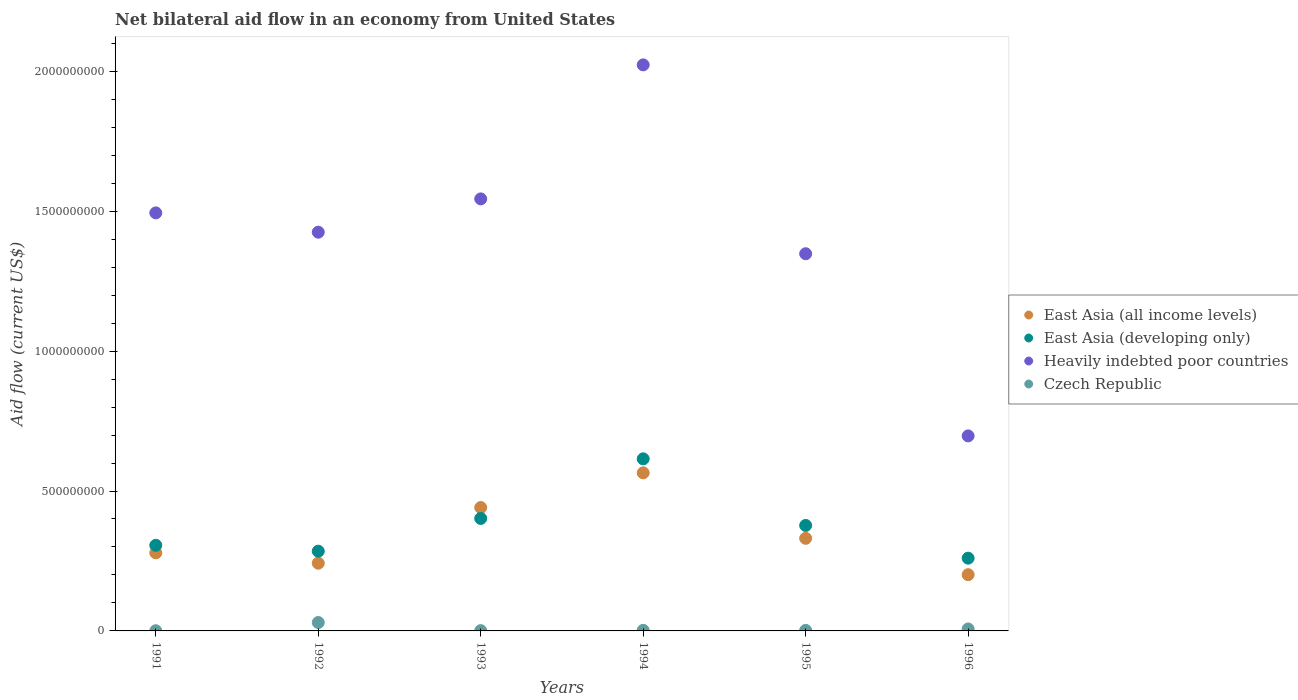How many different coloured dotlines are there?
Provide a succinct answer. 4. What is the net bilateral aid flow in East Asia (all income levels) in 1995?
Provide a succinct answer. 3.31e+08. Across all years, what is the maximum net bilateral aid flow in East Asia (all income levels)?
Keep it short and to the point. 5.65e+08. Across all years, what is the minimum net bilateral aid flow in East Asia (developing only)?
Offer a very short reply. 2.60e+08. In which year was the net bilateral aid flow in East Asia (all income levels) maximum?
Make the answer very short. 1994. What is the total net bilateral aid flow in Heavily indebted poor countries in the graph?
Keep it short and to the point. 8.53e+09. What is the difference between the net bilateral aid flow in East Asia (all income levels) in 1994 and that in 1996?
Your answer should be very brief. 3.64e+08. What is the difference between the net bilateral aid flow in Czech Republic in 1993 and the net bilateral aid flow in East Asia (all income levels) in 1995?
Your answer should be compact. -3.30e+08. What is the average net bilateral aid flow in East Asia (all income levels) per year?
Your answer should be compact. 3.43e+08. In the year 1992, what is the difference between the net bilateral aid flow in East Asia (developing only) and net bilateral aid flow in East Asia (all income levels)?
Provide a short and direct response. 4.30e+07. Is the net bilateral aid flow in East Asia (all income levels) in 1993 less than that in 1996?
Provide a succinct answer. No. Is the difference between the net bilateral aid flow in East Asia (developing only) in 1991 and 1995 greater than the difference between the net bilateral aid flow in East Asia (all income levels) in 1991 and 1995?
Keep it short and to the point. No. What is the difference between the highest and the second highest net bilateral aid flow in Heavily indebted poor countries?
Your answer should be very brief. 4.79e+08. What is the difference between the highest and the lowest net bilateral aid flow in East Asia (developing only)?
Make the answer very short. 3.55e+08. In how many years, is the net bilateral aid flow in Heavily indebted poor countries greater than the average net bilateral aid flow in Heavily indebted poor countries taken over all years?
Provide a succinct answer. 4. Is it the case that in every year, the sum of the net bilateral aid flow in Heavily indebted poor countries and net bilateral aid flow in East Asia (developing only)  is greater than the sum of net bilateral aid flow in East Asia (all income levels) and net bilateral aid flow in Czech Republic?
Keep it short and to the point. Yes. Is the net bilateral aid flow in Heavily indebted poor countries strictly greater than the net bilateral aid flow in East Asia (developing only) over the years?
Keep it short and to the point. Yes. Is the net bilateral aid flow in East Asia (developing only) strictly less than the net bilateral aid flow in Heavily indebted poor countries over the years?
Make the answer very short. Yes. How many dotlines are there?
Your answer should be compact. 4. What is the difference between two consecutive major ticks on the Y-axis?
Your response must be concise. 5.00e+08. Does the graph contain any zero values?
Ensure brevity in your answer.  No. Does the graph contain grids?
Your answer should be compact. No. Where does the legend appear in the graph?
Offer a very short reply. Center right. How are the legend labels stacked?
Your answer should be compact. Vertical. What is the title of the graph?
Your answer should be very brief. Net bilateral aid flow in an economy from United States. Does "Bosnia and Herzegovina" appear as one of the legend labels in the graph?
Your answer should be very brief. No. What is the Aid flow (current US$) of East Asia (all income levels) in 1991?
Your answer should be very brief. 2.79e+08. What is the Aid flow (current US$) in East Asia (developing only) in 1991?
Make the answer very short. 3.06e+08. What is the Aid flow (current US$) of Heavily indebted poor countries in 1991?
Provide a short and direct response. 1.49e+09. What is the Aid flow (current US$) in Czech Republic in 1991?
Your answer should be very brief. 7.00e+05. What is the Aid flow (current US$) in East Asia (all income levels) in 1992?
Your answer should be very brief. 2.42e+08. What is the Aid flow (current US$) of East Asia (developing only) in 1992?
Your response must be concise. 2.85e+08. What is the Aid flow (current US$) of Heavily indebted poor countries in 1992?
Your response must be concise. 1.42e+09. What is the Aid flow (current US$) in Czech Republic in 1992?
Offer a terse response. 3.00e+07. What is the Aid flow (current US$) of East Asia (all income levels) in 1993?
Give a very brief answer. 4.41e+08. What is the Aid flow (current US$) of East Asia (developing only) in 1993?
Your answer should be compact. 4.02e+08. What is the Aid flow (current US$) in Heavily indebted poor countries in 1993?
Give a very brief answer. 1.54e+09. What is the Aid flow (current US$) of Czech Republic in 1993?
Your response must be concise. 1.00e+06. What is the Aid flow (current US$) of East Asia (all income levels) in 1994?
Provide a short and direct response. 5.65e+08. What is the Aid flow (current US$) in East Asia (developing only) in 1994?
Provide a short and direct response. 6.15e+08. What is the Aid flow (current US$) of Heavily indebted poor countries in 1994?
Make the answer very short. 2.02e+09. What is the Aid flow (current US$) in East Asia (all income levels) in 1995?
Provide a short and direct response. 3.31e+08. What is the Aid flow (current US$) of East Asia (developing only) in 1995?
Give a very brief answer. 3.77e+08. What is the Aid flow (current US$) of Heavily indebted poor countries in 1995?
Your answer should be compact. 1.35e+09. What is the Aid flow (current US$) in Czech Republic in 1995?
Ensure brevity in your answer.  2.00e+06. What is the Aid flow (current US$) of East Asia (all income levels) in 1996?
Provide a succinct answer. 2.01e+08. What is the Aid flow (current US$) in East Asia (developing only) in 1996?
Your response must be concise. 2.60e+08. What is the Aid flow (current US$) in Heavily indebted poor countries in 1996?
Provide a short and direct response. 6.97e+08. What is the Aid flow (current US$) of Czech Republic in 1996?
Give a very brief answer. 7.00e+06. Across all years, what is the maximum Aid flow (current US$) in East Asia (all income levels)?
Offer a terse response. 5.65e+08. Across all years, what is the maximum Aid flow (current US$) of East Asia (developing only)?
Provide a succinct answer. 6.15e+08. Across all years, what is the maximum Aid flow (current US$) of Heavily indebted poor countries?
Your response must be concise. 2.02e+09. Across all years, what is the maximum Aid flow (current US$) of Czech Republic?
Make the answer very short. 3.00e+07. Across all years, what is the minimum Aid flow (current US$) of East Asia (all income levels)?
Give a very brief answer. 2.01e+08. Across all years, what is the minimum Aid flow (current US$) of East Asia (developing only)?
Make the answer very short. 2.60e+08. Across all years, what is the minimum Aid flow (current US$) of Heavily indebted poor countries?
Provide a short and direct response. 6.97e+08. Across all years, what is the minimum Aid flow (current US$) in Czech Republic?
Your answer should be compact. 7.00e+05. What is the total Aid flow (current US$) of East Asia (all income levels) in the graph?
Offer a very short reply. 2.06e+09. What is the total Aid flow (current US$) in East Asia (developing only) in the graph?
Offer a terse response. 2.24e+09. What is the total Aid flow (current US$) in Heavily indebted poor countries in the graph?
Offer a very short reply. 8.53e+09. What is the total Aid flow (current US$) in Czech Republic in the graph?
Give a very brief answer. 4.27e+07. What is the difference between the Aid flow (current US$) in East Asia (all income levels) in 1991 and that in 1992?
Give a very brief answer. 3.70e+07. What is the difference between the Aid flow (current US$) of East Asia (developing only) in 1991 and that in 1992?
Your answer should be compact. 2.10e+07. What is the difference between the Aid flow (current US$) of Heavily indebted poor countries in 1991 and that in 1992?
Provide a short and direct response. 6.90e+07. What is the difference between the Aid flow (current US$) of Czech Republic in 1991 and that in 1992?
Your response must be concise. -2.93e+07. What is the difference between the Aid flow (current US$) of East Asia (all income levels) in 1991 and that in 1993?
Offer a very short reply. -1.62e+08. What is the difference between the Aid flow (current US$) in East Asia (developing only) in 1991 and that in 1993?
Offer a terse response. -9.60e+07. What is the difference between the Aid flow (current US$) of Heavily indebted poor countries in 1991 and that in 1993?
Keep it short and to the point. -5.00e+07. What is the difference between the Aid flow (current US$) of East Asia (all income levels) in 1991 and that in 1994?
Offer a very short reply. -2.86e+08. What is the difference between the Aid flow (current US$) in East Asia (developing only) in 1991 and that in 1994?
Keep it short and to the point. -3.09e+08. What is the difference between the Aid flow (current US$) in Heavily indebted poor countries in 1991 and that in 1994?
Provide a succinct answer. -5.29e+08. What is the difference between the Aid flow (current US$) in Czech Republic in 1991 and that in 1994?
Offer a very short reply. -1.30e+06. What is the difference between the Aid flow (current US$) of East Asia (all income levels) in 1991 and that in 1995?
Provide a short and direct response. -5.20e+07. What is the difference between the Aid flow (current US$) of East Asia (developing only) in 1991 and that in 1995?
Provide a succinct answer. -7.10e+07. What is the difference between the Aid flow (current US$) of Heavily indebted poor countries in 1991 and that in 1995?
Your response must be concise. 1.46e+08. What is the difference between the Aid flow (current US$) in Czech Republic in 1991 and that in 1995?
Your answer should be very brief. -1.30e+06. What is the difference between the Aid flow (current US$) in East Asia (all income levels) in 1991 and that in 1996?
Keep it short and to the point. 7.80e+07. What is the difference between the Aid flow (current US$) of East Asia (developing only) in 1991 and that in 1996?
Make the answer very short. 4.60e+07. What is the difference between the Aid flow (current US$) of Heavily indebted poor countries in 1991 and that in 1996?
Provide a short and direct response. 7.97e+08. What is the difference between the Aid flow (current US$) in Czech Republic in 1991 and that in 1996?
Provide a short and direct response. -6.30e+06. What is the difference between the Aid flow (current US$) of East Asia (all income levels) in 1992 and that in 1993?
Offer a very short reply. -1.99e+08. What is the difference between the Aid flow (current US$) of East Asia (developing only) in 1992 and that in 1993?
Give a very brief answer. -1.17e+08. What is the difference between the Aid flow (current US$) in Heavily indebted poor countries in 1992 and that in 1993?
Give a very brief answer. -1.19e+08. What is the difference between the Aid flow (current US$) of Czech Republic in 1992 and that in 1993?
Provide a short and direct response. 2.90e+07. What is the difference between the Aid flow (current US$) of East Asia (all income levels) in 1992 and that in 1994?
Your answer should be very brief. -3.23e+08. What is the difference between the Aid flow (current US$) in East Asia (developing only) in 1992 and that in 1994?
Make the answer very short. -3.30e+08. What is the difference between the Aid flow (current US$) in Heavily indebted poor countries in 1992 and that in 1994?
Offer a very short reply. -5.98e+08. What is the difference between the Aid flow (current US$) of Czech Republic in 1992 and that in 1994?
Offer a very short reply. 2.80e+07. What is the difference between the Aid flow (current US$) in East Asia (all income levels) in 1992 and that in 1995?
Provide a short and direct response. -8.90e+07. What is the difference between the Aid flow (current US$) of East Asia (developing only) in 1992 and that in 1995?
Keep it short and to the point. -9.20e+07. What is the difference between the Aid flow (current US$) of Heavily indebted poor countries in 1992 and that in 1995?
Provide a short and direct response. 7.70e+07. What is the difference between the Aid flow (current US$) of Czech Republic in 1992 and that in 1995?
Offer a very short reply. 2.80e+07. What is the difference between the Aid flow (current US$) in East Asia (all income levels) in 1992 and that in 1996?
Your response must be concise. 4.10e+07. What is the difference between the Aid flow (current US$) in East Asia (developing only) in 1992 and that in 1996?
Your response must be concise. 2.50e+07. What is the difference between the Aid flow (current US$) of Heavily indebted poor countries in 1992 and that in 1996?
Keep it short and to the point. 7.28e+08. What is the difference between the Aid flow (current US$) in Czech Republic in 1992 and that in 1996?
Make the answer very short. 2.30e+07. What is the difference between the Aid flow (current US$) in East Asia (all income levels) in 1993 and that in 1994?
Give a very brief answer. -1.24e+08. What is the difference between the Aid flow (current US$) in East Asia (developing only) in 1993 and that in 1994?
Provide a succinct answer. -2.13e+08. What is the difference between the Aid flow (current US$) in Heavily indebted poor countries in 1993 and that in 1994?
Your answer should be compact. -4.79e+08. What is the difference between the Aid flow (current US$) in Czech Republic in 1993 and that in 1994?
Make the answer very short. -1.00e+06. What is the difference between the Aid flow (current US$) of East Asia (all income levels) in 1993 and that in 1995?
Keep it short and to the point. 1.10e+08. What is the difference between the Aid flow (current US$) of East Asia (developing only) in 1993 and that in 1995?
Your answer should be compact. 2.50e+07. What is the difference between the Aid flow (current US$) of Heavily indebted poor countries in 1993 and that in 1995?
Ensure brevity in your answer.  1.96e+08. What is the difference between the Aid flow (current US$) in Czech Republic in 1993 and that in 1995?
Ensure brevity in your answer.  -1.00e+06. What is the difference between the Aid flow (current US$) of East Asia (all income levels) in 1993 and that in 1996?
Ensure brevity in your answer.  2.40e+08. What is the difference between the Aid flow (current US$) in East Asia (developing only) in 1993 and that in 1996?
Offer a terse response. 1.42e+08. What is the difference between the Aid flow (current US$) of Heavily indebted poor countries in 1993 and that in 1996?
Your answer should be compact. 8.47e+08. What is the difference between the Aid flow (current US$) of Czech Republic in 1993 and that in 1996?
Provide a short and direct response. -6.00e+06. What is the difference between the Aid flow (current US$) of East Asia (all income levels) in 1994 and that in 1995?
Keep it short and to the point. 2.34e+08. What is the difference between the Aid flow (current US$) of East Asia (developing only) in 1994 and that in 1995?
Offer a terse response. 2.38e+08. What is the difference between the Aid flow (current US$) of Heavily indebted poor countries in 1994 and that in 1995?
Ensure brevity in your answer.  6.75e+08. What is the difference between the Aid flow (current US$) in East Asia (all income levels) in 1994 and that in 1996?
Ensure brevity in your answer.  3.64e+08. What is the difference between the Aid flow (current US$) of East Asia (developing only) in 1994 and that in 1996?
Offer a terse response. 3.55e+08. What is the difference between the Aid flow (current US$) of Heavily indebted poor countries in 1994 and that in 1996?
Keep it short and to the point. 1.33e+09. What is the difference between the Aid flow (current US$) in Czech Republic in 1994 and that in 1996?
Provide a short and direct response. -5.00e+06. What is the difference between the Aid flow (current US$) in East Asia (all income levels) in 1995 and that in 1996?
Provide a succinct answer. 1.30e+08. What is the difference between the Aid flow (current US$) in East Asia (developing only) in 1995 and that in 1996?
Offer a terse response. 1.17e+08. What is the difference between the Aid flow (current US$) of Heavily indebted poor countries in 1995 and that in 1996?
Your answer should be compact. 6.51e+08. What is the difference between the Aid flow (current US$) of Czech Republic in 1995 and that in 1996?
Make the answer very short. -5.00e+06. What is the difference between the Aid flow (current US$) in East Asia (all income levels) in 1991 and the Aid flow (current US$) in East Asia (developing only) in 1992?
Your answer should be compact. -6.00e+06. What is the difference between the Aid flow (current US$) of East Asia (all income levels) in 1991 and the Aid flow (current US$) of Heavily indebted poor countries in 1992?
Make the answer very short. -1.15e+09. What is the difference between the Aid flow (current US$) in East Asia (all income levels) in 1991 and the Aid flow (current US$) in Czech Republic in 1992?
Provide a short and direct response. 2.49e+08. What is the difference between the Aid flow (current US$) of East Asia (developing only) in 1991 and the Aid flow (current US$) of Heavily indebted poor countries in 1992?
Ensure brevity in your answer.  -1.12e+09. What is the difference between the Aid flow (current US$) in East Asia (developing only) in 1991 and the Aid flow (current US$) in Czech Republic in 1992?
Offer a very short reply. 2.76e+08. What is the difference between the Aid flow (current US$) of Heavily indebted poor countries in 1991 and the Aid flow (current US$) of Czech Republic in 1992?
Make the answer very short. 1.46e+09. What is the difference between the Aid flow (current US$) in East Asia (all income levels) in 1991 and the Aid flow (current US$) in East Asia (developing only) in 1993?
Offer a very short reply. -1.23e+08. What is the difference between the Aid flow (current US$) of East Asia (all income levels) in 1991 and the Aid flow (current US$) of Heavily indebted poor countries in 1993?
Offer a very short reply. -1.26e+09. What is the difference between the Aid flow (current US$) in East Asia (all income levels) in 1991 and the Aid flow (current US$) in Czech Republic in 1993?
Offer a very short reply. 2.78e+08. What is the difference between the Aid flow (current US$) in East Asia (developing only) in 1991 and the Aid flow (current US$) in Heavily indebted poor countries in 1993?
Your answer should be compact. -1.24e+09. What is the difference between the Aid flow (current US$) in East Asia (developing only) in 1991 and the Aid flow (current US$) in Czech Republic in 1993?
Your response must be concise. 3.05e+08. What is the difference between the Aid flow (current US$) in Heavily indebted poor countries in 1991 and the Aid flow (current US$) in Czech Republic in 1993?
Your answer should be compact. 1.49e+09. What is the difference between the Aid flow (current US$) of East Asia (all income levels) in 1991 and the Aid flow (current US$) of East Asia (developing only) in 1994?
Make the answer very short. -3.36e+08. What is the difference between the Aid flow (current US$) of East Asia (all income levels) in 1991 and the Aid flow (current US$) of Heavily indebted poor countries in 1994?
Give a very brief answer. -1.74e+09. What is the difference between the Aid flow (current US$) of East Asia (all income levels) in 1991 and the Aid flow (current US$) of Czech Republic in 1994?
Provide a short and direct response. 2.77e+08. What is the difference between the Aid flow (current US$) of East Asia (developing only) in 1991 and the Aid flow (current US$) of Heavily indebted poor countries in 1994?
Your answer should be compact. -1.72e+09. What is the difference between the Aid flow (current US$) of East Asia (developing only) in 1991 and the Aid flow (current US$) of Czech Republic in 1994?
Give a very brief answer. 3.04e+08. What is the difference between the Aid flow (current US$) of Heavily indebted poor countries in 1991 and the Aid flow (current US$) of Czech Republic in 1994?
Provide a short and direct response. 1.49e+09. What is the difference between the Aid flow (current US$) in East Asia (all income levels) in 1991 and the Aid flow (current US$) in East Asia (developing only) in 1995?
Your answer should be compact. -9.80e+07. What is the difference between the Aid flow (current US$) in East Asia (all income levels) in 1991 and the Aid flow (current US$) in Heavily indebted poor countries in 1995?
Give a very brief answer. -1.07e+09. What is the difference between the Aid flow (current US$) of East Asia (all income levels) in 1991 and the Aid flow (current US$) of Czech Republic in 1995?
Offer a very short reply. 2.77e+08. What is the difference between the Aid flow (current US$) of East Asia (developing only) in 1991 and the Aid flow (current US$) of Heavily indebted poor countries in 1995?
Your response must be concise. -1.04e+09. What is the difference between the Aid flow (current US$) in East Asia (developing only) in 1991 and the Aid flow (current US$) in Czech Republic in 1995?
Your response must be concise. 3.04e+08. What is the difference between the Aid flow (current US$) of Heavily indebted poor countries in 1991 and the Aid flow (current US$) of Czech Republic in 1995?
Offer a very short reply. 1.49e+09. What is the difference between the Aid flow (current US$) in East Asia (all income levels) in 1991 and the Aid flow (current US$) in East Asia (developing only) in 1996?
Your response must be concise. 1.90e+07. What is the difference between the Aid flow (current US$) in East Asia (all income levels) in 1991 and the Aid flow (current US$) in Heavily indebted poor countries in 1996?
Provide a succinct answer. -4.18e+08. What is the difference between the Aid flow (current US$) of East Asia (all income levels) in 1991 and the Aid flow (current US$) of Czech Republic in 1996?
Give a very brief answer. 2.72e+08. What is the difference between the Aid flow (current US$) of East Asia (developing only) in 1991 and the Aid flow (current US$) of Heavily indebted poor countries in 1996?
Give a very brief answer. -3.91e+08. What is the difference between the Aid flow (current US$) of East Asia (developing only) in 1991 and the Aid flow (current US$) of Czech Republic in 1996?
Keep it short and to the point. 2.99e+08. What is the difference between the Aid flow (current US$) of Heavily indebted poor countries in 1991 and the Aid flow (current US$) of Czech Republic in 1996?
Your answer should be compact. 1.49e+09. What is the difference between the Aid flow (current US$) of East Asia (all income levels) in 1992 and the Aid flow (current US$) of East Asia (developing only) in 1993?
Your response must be concise. -1.60e+08. What is the difference between the Aid flow (current US$) of East Asia (all income levels) in 1992 and the Aid flow (current US$) of Heavily indebted poor countries in 1993?
Make the answer very short. -1.30e+09. What is the difference between the Aid flow (current US$) of East Asia (all income levels) in 1992 and the Aid flow (current US$) of Czech Republic in 1993?
Give a very brief answer. 2.41e+08. What is the difference between the Aid flow (current US$) of East Asia (developing only) in 1992 and the Aid flow (current US$) of Heavily indebted poor countries in 1993?
Offer a terse response. -1.26e+09. What is the difference between the Aid flow (current US$) in East Asia (developing only) in 1992 and the Aid flow (current US$) in Czech Republic in 1993?
Your response must be concise. 2.84e+08. What is the difference between the Aid flow (current US$) in Heavily indebted poor countries in 1992 and the Aid flow (current US$) in Czech Republic in 1993?
Your answer should be very brief. 1.42e+09. What is the difference between the Aid flow (current US$) in East Asia (all income levels) in 1992 and the Aid flow (current US$) in East Asia (developing only) in 1994?
Provide a succinct answer. -3.73e+08. What is the difference between the Aid flow (current US$) in East Asia (all income levels) in 1992 and the Aid flow (current US$) in Heavily indebted poor countries in 1994?
Provide a short and direct response. -1.78e+09. What is the difference between the Aid flow (current US$) of East Asia (all income levels) in 1992 and the Aid flow (current US$) of Czech Republic in 1994?
Ensure brevity in your answer.  2.40e+08. What is the difference between the Aid flow (current US$) in East Asia (developing only) in 1992 and the Aid flow (current US$) in Heavily indebted poor countries in 1994?
Ensure brevity in your answer.  -1.74e+09. What is the difference between the Aid flow (current US$) of East Asia (developing only) in 1992 and the Aid flow (current US$) of Czech Republic in 1994?
Provide a short and direct response. 2.83e+08. What is the difference between the Aid flow (current US$) in Heavily indebted poor countries in 1992 and the Aid flow (current US$) in Czech Republic in 1994?
Ensure brevity in your answer.  1.42e+09. What is the difference between the Aid flow (current US$) of East Asia (all income levels) in 1992 and the Aid flow (current US$) of East Asia (developing only) in 1995?
Ensure brevity in your answer.  -1.35e+08. What is the difference between the Aid flow (current US$) of East Asia (all income levels) in 1992 and the Aid flow (current US$) of Heavily indebted poor countries in 1995?
Your answer should be compact. -1.11e+09. What is the difference between the Aid flow (current US$) of East Asia (all income levels) in 1992 and the Aid flow (current US$) of Czech Republic in 1995?
Your answer should be very brief. 2.40e+08. What is the difference between the Aid flow (current US$) in East Asia (developing only) in 1992 and the Aid flow (current US$) in Heavily indebted poor countries in 1995?
Provide a succinct answer. -1.06e+09. What is the difference between the Aid flow (current US$) of East Asia (developing only) in 1992 and the Aid flow (current US$) of Czech Republic in 1995?
Your answer should be very brief. 2.83e+08. What is the difference between the Aid flow (current US$) of Heavily indebted poor countries in 1992 and the Aid flow (current US$) of Czech Republic in 1995?
Provide a succinct answer. 1.42e+09. What is the difference between the Aid flow (current US$) in East Asia (all income levels) in 1992 and the Aid flow (current US$) in East Asia (developing only) in 1996?
Keep it short and to the point. -1.80e+07. What is the difference between the Aid flow (current US$) of East Asia (all income levels) in 1992 and the Aid flow (current US$) of Heavily indebted poor countries in 1996?
Your answer should be very brief. -4.55e+08. What is the difference between the Aid flow (current US$) in East Asia (all income levels) in 1992 and the Aid flow (current US$) in Czech Republic in 1996?
Give a very brief answer. 2.35e+08. What is the difference between the Aid flow (current US$) of East Asia (developing only) in 1992 and the Aid flow (current US$) of Heavily indebted poor countries in 1996?
Offer a very short reply. -4.12e+08. What is the difference between the Aid flow (current US$) of East Asia (developing only) in 1992 and the Aid flow (current US$) of Czech Republic in 1996?
Give a very brief answer. 2.78e+08. What is the difference between the Aid flow (current US$) of Heavily indebted poor countries in 1992 and the Aid flow (current US$) of Czech Republic in 1996?
Provide a succinct answer. 1.42e+09. What is the difference between the Aid flow (current US$) of East Asia (all income levels) in 1993 and the Aid flow (current US$) of East Asia (developing only) in 1994?
Your answer should be very brief. -1.74e+08. What is the difference between the Aid flow (current US$) of East Asia (all income levels) in 1993 and the Aid flow (current US$) of Heavily indebted poor countries in 1994?
Your response must be concise. -1.58e+09. What is the difference between the Aid flow (current US$) of East Asia (all income levels) in 1993 and the Aid flow (current US$) of Czech Republic in 1994?
Provide a succinct answer. 4.39e+08. What is the difference between the Aid flow (current US$) of East Asia (developing only) in 1993 and the Aid flow (current US$) of Heavily indebted poor countries in 1994?
Make the answer very short. -1.62e+09. What is the difference between the Aid flow (current US$) of East Asia (developing only) in 1993 and the Aid flow (current US$) of Czech Republic in 1994?
Provide a succinct answer. 4.00e+08. What is the difference between the Aid flow (current US$) in Heavily indebted poor countries in 1993 and the Aid flow (current US$) in Czech Republic in 1994?
Your answer should be compact. 1.54e+09. What is the difference between the Aid flow (current US$) of East Asia (all income levels) in 1993 and the Aid flow (current US$) of East Asia (developing only) in 1995?
Offer a very short reply. 6.40e+07. What is the difference between the Aid flow (current US$) in East Asia (all income levels) in 1993 and the Aid flow (current US$) in Heavily indebted poor countries in 1995?
Offer a terse response. -9.07e+08. What is the difference between the Aid flow (current US$) of East Asia (all income levels) in 1993 and the Aid flow (current US$) of Czech Republic in 1995?
Offer a very short reply. 4.39e+08. What is the difference between the Aid flow (current US$) in East Asia (developing only) in 1993 and the Aid flow (current US$) in Heavily indebted poor countries in 1995?
Your answer should be compact. -9.46e+08. What is the difference between the Aid flow (current US$) of East Asia (developing only) in 1993 and the Aid flow (current US$) of Czech Republic in 1995?
Provide a short and direct response. 4.00e+08. What is the difference between the Aid flow (current US$) of Heavily indebted poor countries in 1993 and the Aid flow (current US$) of Czech Republic in 1995?
Your answer should be compact. 1.54e+09. What is the difference between the Aid flow (current US$) of East Asia (all income levels) in 1993 and the Aid flow (current US$) of East Asia (developing only) in 1996?
Keep it short and to the point. 1.81e+08. What is the difference between the Aid flow (current US$) of East Asia (all income levels) in 1993 and the Aid flow (current US$) of Heavily indebted poor countries in 1996?
Make the answer very short. -2.56e+08. What is the difference between the Aid flow (current US$) of East Asia (all income levels) in 1993 and the Aid flow (current US$) of Czech Republic in 1996?
Your answer should be very brief. 4.34e+08. What is the difference between the Aid flow (current US$) in East Asia (developing only) in 1993 and the Aid flow (current US$) in Heavily indebted poor countries in 1996?
Provide a short and direct response. -2.95e+08. What is the difference between the Aid flow (current US$) of East Asia (developing only) in 1993 and the Aid flow (current US$) of Czech Republic in 1996?
Your answer should be compact. 3.95e+08. What is the difference between the Aid flow (current US$) of Heavily indebted poor countries in 1993 and the Aid flow (current US$) of Czech Republic in 1996?
Keep it short and to the point. 1.54e+09. What is the difference between the Aid flow (current US$) of East Asia (all income levels) in 1994 and the Aid flow (current US$) of East Asia (developing only) in 1995?
Provide a short and direct response. 1.88e+08. What is the difference between the Aid flow (current US$) in East Asia (all income levels) in 1994 and the Aid flow (current US$) in Heavily indebted poor countries in 1995?
Give a very brief answer. -7.83e+08. What is the difference between the Aid flow (current US$) of East Asia (all income levels) in 1994 and the Aid flow (current US$) of Czech Republic in 1995?
Offer a terse response. 5.63e+08. What is the difference between the Aid flow (current US$) of East Asia (developing only) in 1994 and the Aid flow (current US$) of Heavily indebted poor countries in 1995?
Provide a succinct answer. -7.33e+08. What is the difference between the Aid flow (current US$) of East Asia (developing only) in 1994 and the Aid flow (current US$) of Czech Republic in 1995?
Provide a succinct answer. 6.13e+08. What is the difference between the Aid flow (current US$) of Heavily indebted poor countries in 1994 and the Aid flow (current US$) of Czech Republic in 1995?
Ensure brevity in your answer.  2.02e+09. What is the difference between the Aid flow (current US$) of East Asia (all income levels) in 1994 and the Aid flow (current US$) of East Asia (developing only) in 1996?
Keep it short and to the point. 3.05e+08. What is the difference between the Aid flow (current US$) of East Asia (all income levels) in 1994 and the Aid flow (current US$) of Heavily indebted poor countries in 1996?
Your response must be concise. -1.32e+08. What is the difference between the Aid flow (current US$) in East Asia (all income levels) in 1994 and the Aid flow (current US$) in Czech Republic in 1996?
Offer a very short reply. 5.58e+08. What is the difference between the Aid flow (current US$) in East Asia (developing only) in 1994 and the Aid flow (current US$) in Heavily indebted poor countries in 1996?
Provide a short and direct response. -8.20e+07. What is the difference between the Aid flow (current US$) in East Asia (developing only) in 1994 and the Aid flow (current US$) in Czech Republic in 1996?
Provide a succinct answer. 6.08e+08. What is the difference between the Aid flow (current US$) in Heavily indebted poor countries in 1994 and the Aid flow (current US$) in Czech Republic in 1996?
Keep it short and to the point. 2.02e+09. What is the difference between the Aid flow (current US$) in East Asia (all income levels) in 1995 and the Aid flow (current US$) in East Asia (developing only) in 1996?
Give a very brief answer. 7.10e+07. What is the difference between the Aid flow (current US$) in East Asia (all income levels) in 1995 and the Aid flow (current US$) in Heavily indebted poor countries in 1996?
Your answer should be compact. -3.66e+08. What is the difference between the Aid flow (current US$) of East Asia (all income levels) in 1995 and the Aid flow (current US$) of Czech Republic in 1996?
Give a very brief answer. 3.24e+08. What is the difference between the Aid flow (current US$) of East Asia (developing only) in 1995 and the Aid flow (current US$) of Heavily indebted poor countries in 1996?
Give a very brief answer. -3.20e+08. What is the difference between the Aid flow (current US$) in East Asia (developing only) in 1995 and the Aid flow (current US$) in Czech Republic in 1996?
Keep it short and to the point. 3.70e+08. What is the difference between the Aid flow (current US$) in Heavily indebted poor countries in 1995 and the Aid flow (current US$) in Czech Republic in 1996?
Keep it short and to the point. 1.34e+09. What is the average Aid flow (current US$) of East Asia (all income levels) per year?
Give a very brief answer. 3.43e+08. What is the average Aid flow (current US$) of East Asia (developing only) per year?
Provide a short and direct response. 3.74e+08. What is the average Aid flow (current US$) in Heavily indebted poor countries per year?
Your answer should be compact. 1.42e+09. What is the average Aid flow (current US$) in Czech Republic per year?
Your response must be concise. 7.12e+06. In the year 1991, what is the difference between the Aid flow (current US$) of East Asia (all income levels) and Aid flow (current US$) of East Asia (developing only)?
Provide a succinct answer. -2.70e+07. In the year 1991, what is the difference between the Aid flow (current US$) of East Asia (all income levels) and Aid flow (current US$) of Heavily indebted poor countries?
Provide a succinct answer. -1.22e+09. In the year 1991, what is the difference between the Aid flow (current US$) in East Asia (all income levels) and Aid flow (current US$) in Czech Republic?
Your answer should be compact. 2.78e+08. In the year 1991, what is the difference between the Aid flow (current US$) of East Asia (developing only) and Aid flow (current US$) of Heavily indebted poor countries?
Keep it short and to the point. -1.19e+09. In the year 1991, what is the difference between the Aid flow (current US$) of East Asia (developing only) and Aid flow (current US$) of Czech Republic?
Your answer should be compact. 3.05e+08. In the year 1991, what is the difference between the Aid flow (current US$) in Heavily indebted poor countries and Aid flow (current US$) in Czech Republic?
Make the answer very short. 1.49e+09. In the year 1992, what is the difference between the Aid flow (current US$) of East Asia (all income levels) and Aid flow (current US$) of East Asia (developing only)?
Keep it short and to the point. -4.30e+07. In the year 1992, what is the difference between the Aid flow (current US$) in East Asia (all income levels) and Aid flow (current US$) in Heavily indebted poor countries?
Your answer should be very brief. -1.18e+09. In the year 1992, what is the difference between the Aid flow (current US$) of East Asia (all income levels) and Aid flow (current US$) of Czech Republic?
Provide a short and direct response. 2.12e+08. In the year 1992, what is the difference between the Aid flow (current US$) of East Asia (developing only) and Aid flow (current US$) of Heavily indebted poor countries?
Your answer should be compact. -1.14e+09. In the year 1992, what is the difference between the Aid flow (current US$) of East Asia (developing only) and Aid flow (current US$) of Czech Republic?
Offer a terse response. 2.55e+08. In the year 1992, what is the difference between the Aid flow (current US$) of Heavily indebted poor countries and Aid flow (current US$) of Czech Republic?
Provide a short and direct response. 1.40e+09. In the year 1993, what is the difference between the Aid flow (current US$) in East Asia (all income levels) and Aid flow (current US$) in East Asia (developing only)?
Your response must be concise. 3.90e+07. In the year 1993, what is the difference between the Aid flow (current US$) in East Asia (all income levels) and Aid flow (current US$) in Heavily indebted poor countries?
Your answer should be very brief. -1.10e+09. In the year 1993, what is the difference between the Aid flow (current US$) in East Asia (all income levels) and Aid flow (current US$) in Czech Republic?
Offer a terse response. 4.40e+08. In the year 1993, what is the difference between the Aid flow (current US$) in East Asia (developing only) and Aid flow (current US$) in Heavily indebted poor countries?
Offer a very short reply. -1.14e+09. In the year 1993, what is the difference between the Aid flow (current US$) of East Asia (developing only) and Aid flow (current US$) of Czech Republic?
Offer a very short reply. 4.01e+08. In the year 1993, what is the difference between the Aid flow (current US$) of Heavily indebted poor countries and Aid flow (current US$) of Czech Republic?
Your response must be concise. 1.54e+09. In the year 1994, what is the difference between the Aid flow (current US$) in East Asia (all income levels) and Aid flow (current US$) in East Asia (developing only)?
Your response must be concise. -5.00e+07. In the year 1994, what is the difference between the Aid flow (current US$) in East Asia (all income levels) and Aid flow (current US$) in Heavily indebted poor countries?
Give a very brief answer. -1.46e+09. In the year 1994, what is the difference between the Aid flow (current US$) in East Asia (all income levels) and Aid flow (current US$) in Czech Republic?
Provide a succinct answer. 5.63e+08. In the year 1994, what is the difference between the Aid flow (current US$) in East Asia (developing only) and Aid flow (current US$) in Heavily indebted poor countries?
Ensure brevity in your answer.  -1.41e+09. In the year 1994, what is the difference between the Aid flow (current US$) in East Asia (developing only) and Aid flow (current US$) in Czech Republic?
Your answer should be very brief. 6.13e+08. In the year 1994, what is the difference between the Aid flow (current US$) of Heavily indebted poor countries and Aid flow (current US$) of Czech Republic?
Your answer should be compact. 2.02e+09. In the year 1995, what is the difference between the Aid flow (current US$) of East Asia (all income levels) and Aid flow (current US$) of East Asia (developing only)?
Your answer should be compact. -4.60e+07. In the year 1995, what is the difference between the Aid flow (current US$) of East Asia (all income levels) and Aid flow (current US$) of Heavily indebted poor countries?
Your answer should be very brief. -1.02e+09. In the year 1995, what is the difference between the Aid flow (current US$) in East Asia (all income levels) and Aid flow (current US$) in Czech Republic?
Offer a very short reply. 3.29e+08. In the year 1995, what is the difference between the Aid flow (current US$) of East Asia (developing only) and Aid flow (current US$) of Heavily indebted poor countries?
Provide a succinct answer. -9.71e+08. In the year 1995, what is the difference between the Aid flow (current US$) of East Asia (developing only) and Aid flow (current US$) of Czech Republic?
Provide a short and direct response. 3.75e+08. In the year 1995, what is the difference between the Aid flow (current US$) in Heavily indebted poor countries and Aid flow (current US$) in Czech Republic?
Give a very brief answer. 1.35e+09. In the year 1996, what is the difference between the Aid flow (current US$) in East Asia (all income levels) and Aid flow (current US$) in East Asia (developing only)?
Offer a terse response. -5.90e+07. In the year 1996, what is the difference between the Aid flow (current US$) in East Asia (all income levels) and Aid flow (current US$) in Heavily indebted poor countries?
Ensure brevity in your answer.  -4.96e+08. In the year 1996, what is the difference between the Aid flow (current US$) in East Asia (all income levels) and Aid flow (current US$) in Czech Republic?
Offer a terse response. 1.94e+08. In the year 1996, what is the difference between the Aid flow (current US$) in East Asia (developing only) and Aid flow (current US$) in Heavily indebted poor countries?
Ensure brevity in your answer.  -4.37e+08. In the year 1996, what is the difference between the Aid flow (current US$) of East Asia (developing only) and Aid flow (current US$) of Czech Republic?
Your response must be concise. 2.53e+08. In the year 1996, what is the difference between the Aid flow (current US$) in Heavily indebted poor countries and Aid flow (current US$) in Czech Republic?
Your answer should be very brief. 6.90e+08. What is the ratio of the Aid flow (current US$) of East Asia (all income levels) in 1991 to that in 1992?
Your answer should be compact. 1.15. What is the ratio of the Aid flow (current US$) of East Asia (developing only) in 1991 to that in 1992?
Your answer should be very brief. 1.07. What is the ratio of the Aid flow (current US$) in Heavily indebted poor countries in 1991 to that in 1992?
Ensure brevity in your answer.  1.05. What is the ratio of the Aid flow (current US$) of Czech Republic in 1991 to that in 1992?
Give a very brief answer. 0.02. What is the ratio of the Aid flow (current US$) of East Asia (all income levels) in 1991 to that in 1993?
Your answer should be very brief. 0.63. What is the ratio of the Aid flow (current US$) of East Asia (developing only) in 1991 to that in 1993?
Provide a short and direct response. 0.76. What is the ratio of the Aid flow (current US$) in Heavily indebted poor countries in 1991 to that in 1993?
Your response must be concise. 0.97. What is the ratio of the Aid flow (current US$) in Czech Republic in 1991 to that in 1993?
Keep it short and to the point. 0.7. What is the ratio of the Aid flow (current US$) in East Asia (all income levels) in 1991 to that in 1994?
Keep it short and to the point. 0.49. What is the ratio of the Aid flow (current US$) of East Asia (developing only) in 1991 to that in 1994?
Your answer should be compact. 0.5. What is the ratio of the Aid flow (current US$) of Heavily indebted poor countries in 1991 to that in 1994?
Ensure brevity in your answer.  0.74. What is the ratio of the Aid flow (current US$) of East Asia (all income levels) in 1991 to that in 1995?
Your answer should be very brief. 0.84. What is the ratio of the Aid flow (current US$) in East Asia (developing only) in 1991 to that in 1995?
Give a very brief answer. 0.81. What is the ratio of the Aid flow (current US$) of Heavily indebted poor countries in 1991 to that in 1995?
Make the answer very short. 1.11. What is the ratio of the Aid flow (current US$) in East Asia (all income levels) in 1991 to that in 1996?
Ensure brevity in your answer.  1.39. What is the ratio of the Aid flow (current US$) in East Asia (developing only) in 1991 to that in 1996?
Your answer should be compact. 1.18. What is the ratio of the Aid flow (current US$) in Heavily indebted poor countries in 1991 to that in 1996?
Provide a succinct answer. 2.14. What is the ratio of the Aid flow (current US$) of East Asia (all income levels) in 1992 to that in 1993?
Your answer should be compact. 0.55. What is the ratio of the Aid flow (current US$) in East Asia (developing only) in 1992 to that in 1993?
Provide a short and direct response. 0.71. What is the ratio of the Aid flow (current US$) in Heavily indebted poor countries in 1992 to that in 1993?
Provide a short and direct response. 0.92. What is the ratio of the Aid flow (current US$) in Czech Republic in 1992 to that in 1993?
Make the answer very short. 30. What is the ratio of the Aid flow (current US$) of East Asia (all income levels) in 1992 to that in 1994?
Your answer should be very brief. 0.43. What is the ratio of the Aid flow (current US$) of East Asia (developing only) in 1992 to that in 1994?
Your answer should be compact. 0.46. What is the ratio of the Aid flow (current US$) of Heavily indebted poor countries in 1992 to that in 1994?
Give a very brief answer. 0.7. What is the ratio of the Aid flow (current US$) in Czech Republic in 1992 to that in 1994?
Offer a terse response. 15. What is the ratio of the Aid flow (current US$) in East Asia (all income levels) in 1992 to that in 1995?
Offer a very short reply. 0.73. What is the ratio of the Aid flow (current US$) in East Asia (developing only) in 1992 to that in 1995?
Provide a short and direct response. 0.76. What is the ratio of the Aid flow (current US$) of Heavily indebted poor countries in 1992 to that in 1995?
Provide a short and direct response. 1.06. What is the ratio of the Aid flow (current US$) of Czech Republic in 1992 to that in 1995?
Make the answer very short. 15. What is the ratio of the Aid flow (current US$) in East Asia (all income levels) in 1992 to that in 1996?
Provide a succinct answer. 1.2. What is the ratio of the Aid flow (current US$) in East Asia (developing only) in 1992 to that in 1996?
Ensure brevity in your answer.  1.1. What is the ratio of the Aid flow (current US$) of Heavily indebted poor countries in 1992 to that in 1996?
Give a very brief answer. 2.04. What is the ratio of the Aid flow (current US$) in Czech Republic in 1992 to that in 1996?
Your answer should be compact. 4.29. What is the ratio of the Aid flow (current US$) of East Asia (all income levels) in 1993 to that in 1994?
Make the answer very short. 0.78. What is the ratio of the Aid flow (current US$) in East Asia (developing only) in 1993 to that in 1994?
Make the answer very short. 0.65. What is the ratio of the Aid flow (current US$) of Heavily indebted poor countries in 1993 to that in 1994?
Make the answer very short. 0.76. What is the ratio of the Aid flow (current US$) of Czech Republic in 1993 to that in 1994?
Ensure brevity in your answer.  0.5. What is the ratio of the Aid flow (current US$) of East Asia (all income levels) in 1993 to that in 1995?
Give a very brief answer. 1.33. What is the ratio of the Aid flow (current US$) of East Asia (developing only) in 1993 to that in 1995?
Offer a terse response. 1.07. What is the ratio of the Aid flow (current US$) in Heavily indebted poor countries in 1993 to that in 1995?
Provide a short and direct response. 1.15. What is the ratio of the Aid flow (current US$) of Czech Republic in 1993 to that in 1995?
Provide a succinct answer. 0.5. What is the ratio of the Aid flow (current US$) in East Asia (all income levels) in 1993 to that in 1996?
Provide a short and direct response. 2.19. What is the ratio of the Aid flow (current US$) of East Asia (developing only) in 1993 to that in 1996?
Your answer should be very brief. 1.55. What is the ratio of the Aid flow (current US$) of Heavily indebted poor countries in 1993 to that in 1996?
Make the answer very short. 2.22. What is the ratio of the Aid flow (current US$) of Czech Republic in 1993 to that in 1996?
Your answer should be compact. 0.14. What is the ratio of the Aid flow (current US$) in East Asia (all income levels) in 1994 to that in 1995?
Give a very brief answer. 1.71. What is the ratio of the Aid flow (current US$) of East Asia (developing only) in 1994 to that in 1995?
Provide a succinct answer. 1.63. What is the ratio of the Aid flow (current US$) in Heavily indebted poor countries in 1994 to that in 1995?
Keep it short and to the point. 1.5. What is the ratio of the Aid flow (current US$) of East Asia (all income levels) in 1994 to that in 1996?
Your answer should be very brief. 2.81. What is the ratio of the Aid flow (current US$) in East Asia (developing only) in 1994 to that in 1996?
Offer a very short reply. 2.37. What is the ratio of the Aid flow (current US$) of Heavily indebted poor countries in 1994 to that in 1996?
Your answer should be very brief. 2.9. What is the ratio of the Aid flow (current US$) in Czech Republic in 1994 to that in 1996?
Ensure brevity in your answer.  0.29. What is the ratio of the Aid flow (current US$) of East Asia (all income levels) in 1995 to that in 1996?
Provide a short and direct response. 1.65. What is the ratio of the Aid flow (current US$) of East Asia (developing only) in 1995 to that in 1996?
Offer a very short reply. 1.45. What is the ratio of the Aid flow (current US$) of Heavily indebted poor countries in 1995 to that in 1996?
Keep it short and to the point. 1.93. What is the ratio of the Aid flow (current US$) of Czech Republic in 1995 to that in 1996?
Make the answer very short. 0.29. What is the difference between the highest and the second highest Aid flow (current US$) of East Asia (all income levels)?
Your answer should be very brief. 1.24e+08. What is the difference between the highest and the second highest Aid flow (current US$) in East Asia (developing only)?
Your answer should be compact. 2.13e+08. What is the difference between the highest and the second highest Aid flow (current US$) of Heavily indebted poor countries?
Make the answer very short. 4.79e+08. What is the difference between the highest and the second highest Aid flow (current US$) in Czech Republic?
Give a very brief answer. 2.30e+07. What is the difference between the highest and the lowest Aid flow (current US$) of East Asia (all income levels)?
Ensure brevity in your answer.  3.64e+08. What is the difference between the highest and the lowest Aid flow (current US$) in East Asia (developing only)?
Your answer should be very brief. 3.55e+08. What is the difference between the highest and the lowest Aid flow (current US$) in Heavily indebted poor countries?
Offer a terse response. 1.33e+09. What is the difference between the highest and the lowest Aid flow (current US$) in Czech Republic?
Your answer should be very brief. 2.93e+07. 